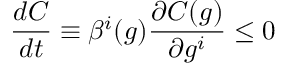<formula> <loc_0><loc_0><loc_500><loc_500>\frac { d C } { d t } \equiv \beta ^ { i } ( g ) \frac { \partial C ( g ) } { \partial g ^ { i } } \leq 0</formula> 